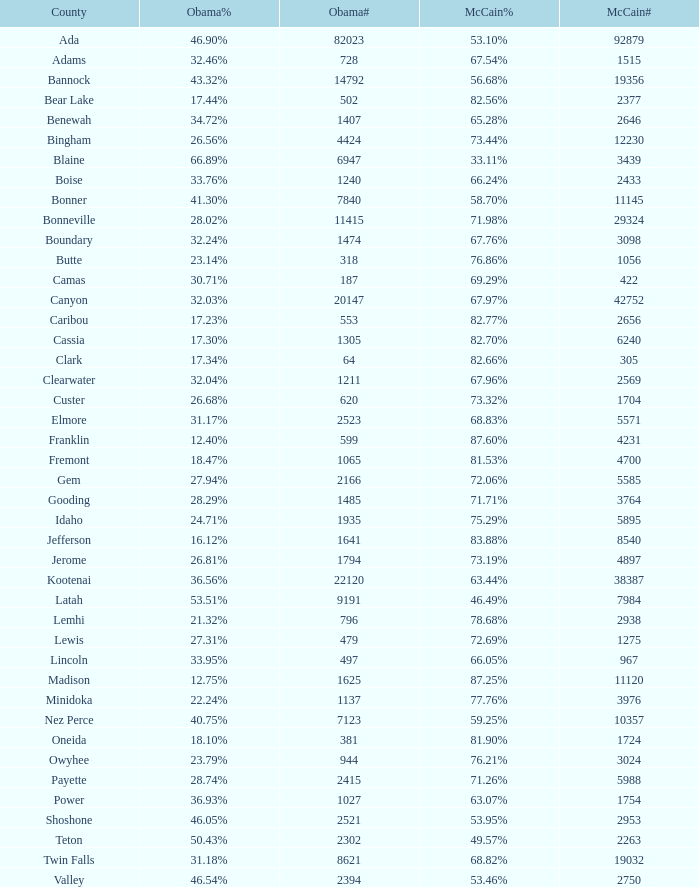What is the peak population turnout for mccain? 92879.0. 